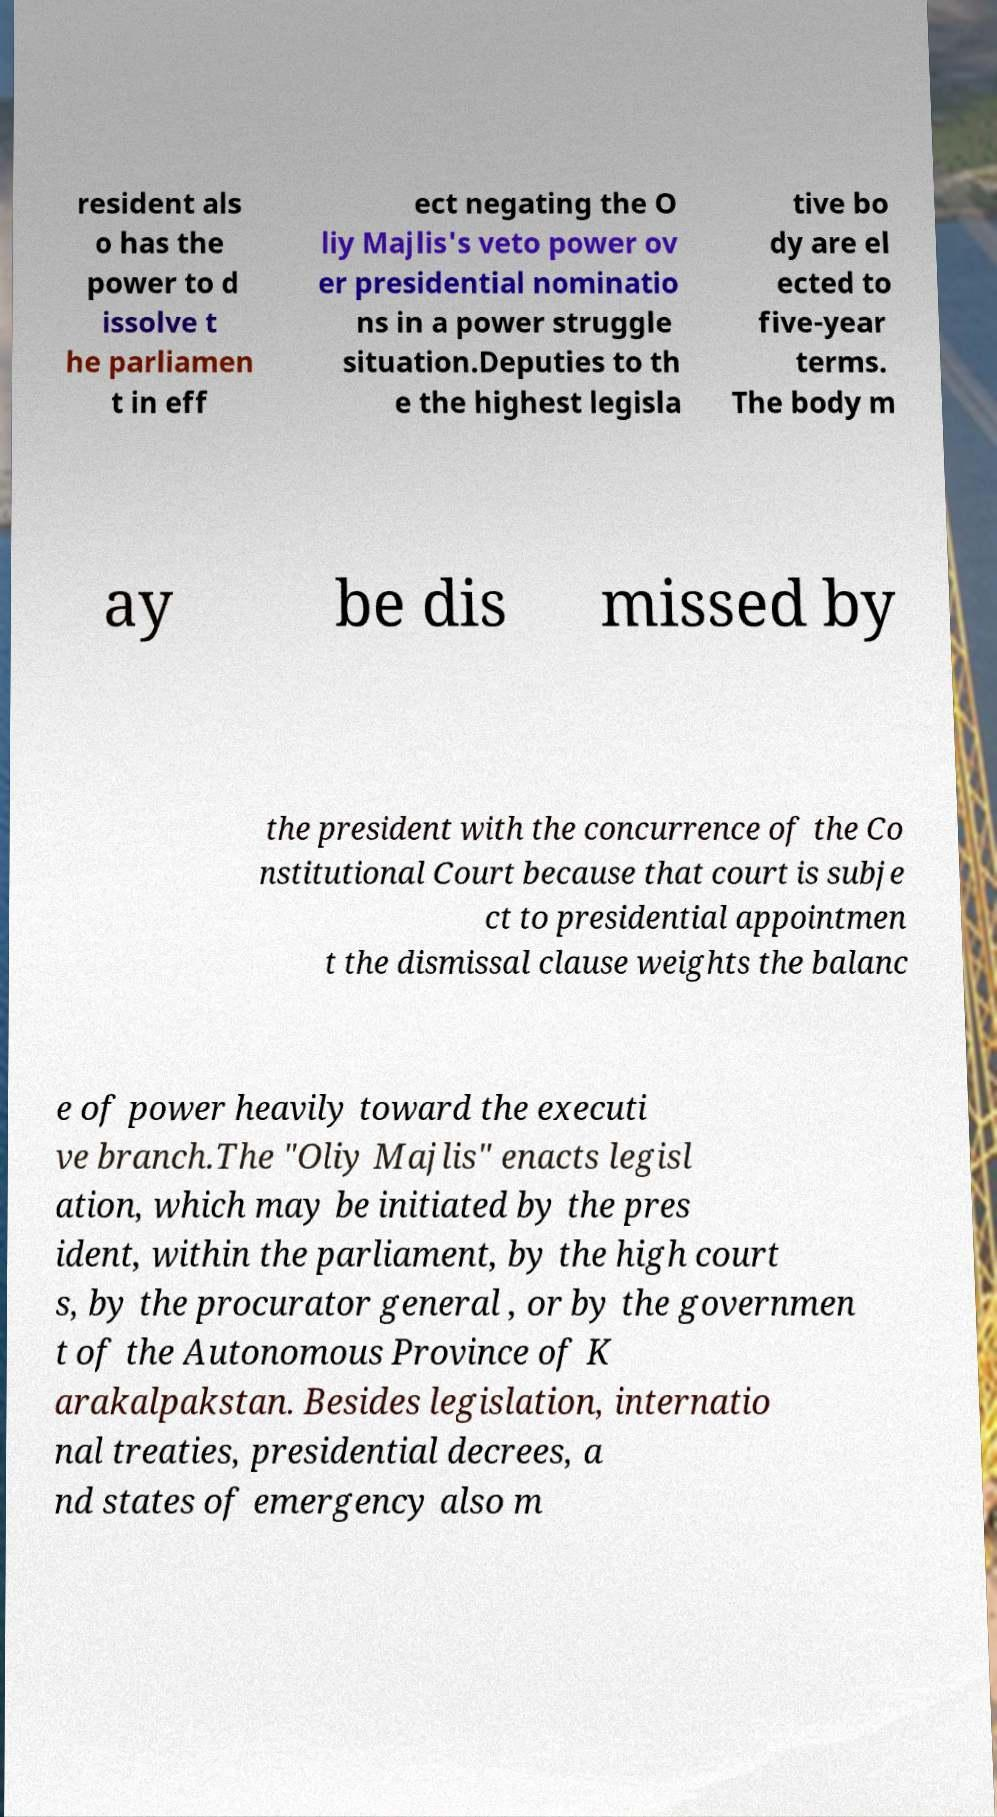For documentation purposes, I need the text within this image transcribed. Could you provide that? resident als o has the power to d issolve t he parliamen t in eff ect negating the O liy Majlis's veto power ov er presidential nominatio ns in a power struggle situation.Deputies to th e the highest legisla tive bo dy are el ected to five-year terms. The body m ay be dis missed by the president with the concurrence of the Co nstitutional Court because that court is subje ct to presidential appointmen t the dismissal clause weights the balanc e of power heavily toward the executi ve branch.The "Oliy Majlis" enacts legisl ation, which may be initiated by the pres ident, within the parliament, by the high court s, by the procurator general , or by the governmen t of the Autonomous Province of K arakalpakstan. Besides legislation, internatio nal treaties, presidential decrees, a nd states of emergency also m 